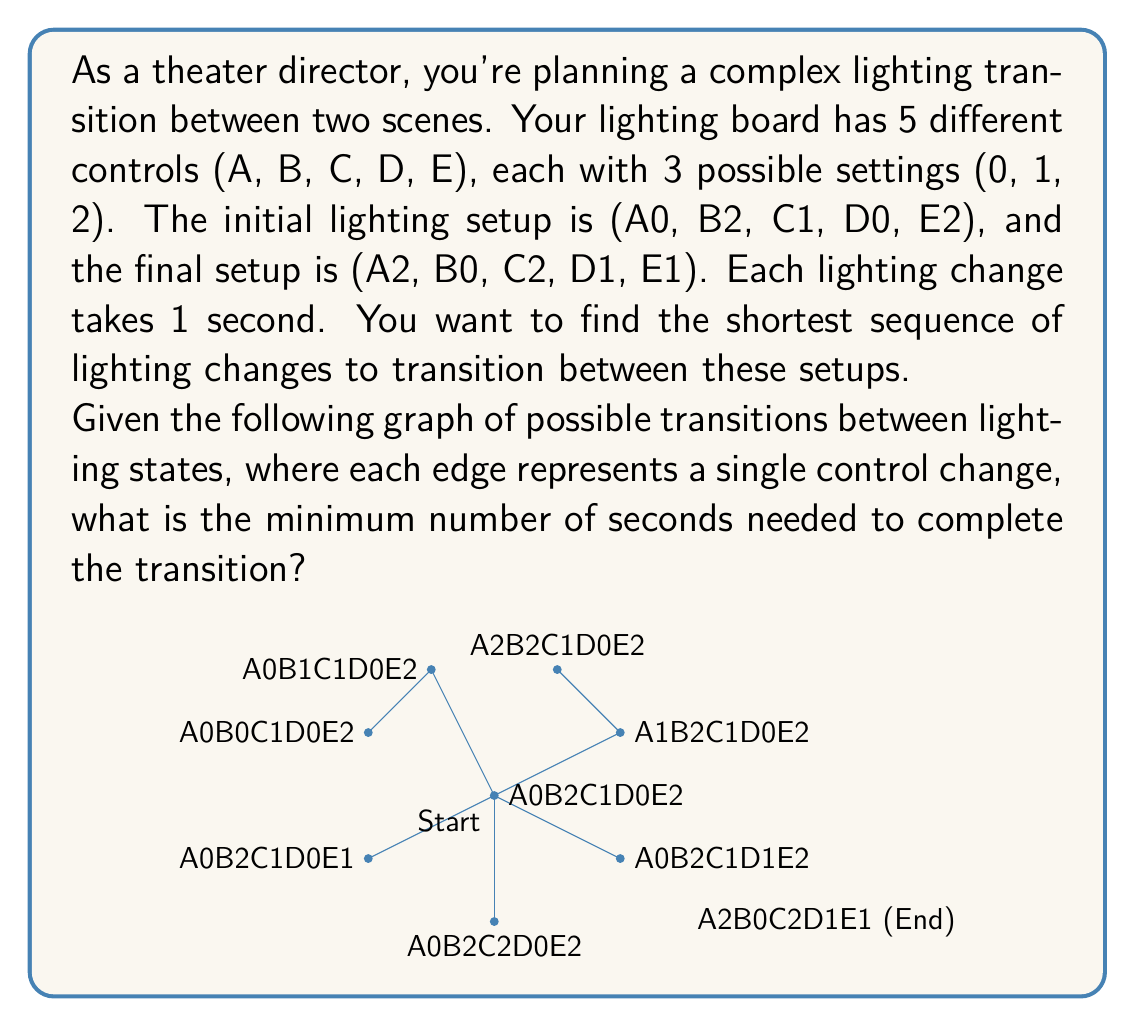Give your solution to this math problem. To solve this problem, we need to use the concept of shortest path in a graph. The given graph represents possible transitions between lighting states, where each edge corresponds to changing one control by one step.

Let's break down the problem:

1) Initial state: A0, B2, C1, D0, E2
   Final state:  A2, B0, C2, D1, E1

2) We need to change:
   A: 0 to 2 (2 steps)
   B: 2 to 0 (2 steps)
   C: 1 to 2 (1 step)
   D: 0 to 1 (1 step)
   E: 2 to 1 (1 step)

3) The total number of individual changes is 2 + 2 + 1 + 1 + 1 = 7

4) In the graph, each edge represents one of these changes. The shortest path from the initial state to the final state will be the one that makes all these changes in the most efficient order.

5) Since there are no restrictions on the order of changes and no states are prohibited, the shortest path will simply make all these changes in any order.

6) The length of this shortest path is equal to the total number of changes required, which is 7.

Therefore, the minimum number of seconds needed to complete the transition is 7, as each change takes 1 second.
Answer: 7 seconds 